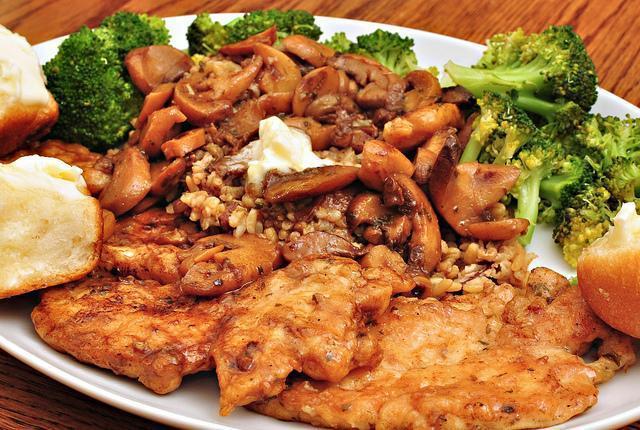How many broccolis are in the picture?
Give a very brief answer. 4. How many chairs with cushions are there?
Give a very brief answer. 0. 